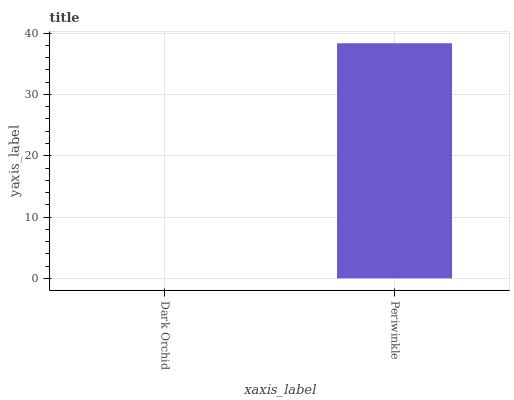Is Dark Orchid the minimum?
Answer yes or no. Yes. Is Periwinkle the maximum?
Answer yes or no. Yes. Is Periwinkle the minimum?
Answer yes or no. No. Is Periwinkle greater than Dark Orchid?
Answer yes or no. Yes. Is Dark Orchid less than Periwinkle?
Answer yes or no. Yes. Is Dark Orchid greater than Periwinkle?
Answer yes or no. No. Is Periwinkle less than Dark Orchid?
Answer yes or no. No. Is Periwinkle the high median?
Answer yes or no. Yes. Is Dark Orchid the low median?
Answer yes or no. Yes. Is Dark Orchid the high median?
Answer yes or no. No. Is Periwinkle the low median?
Answer yes or no. No. 